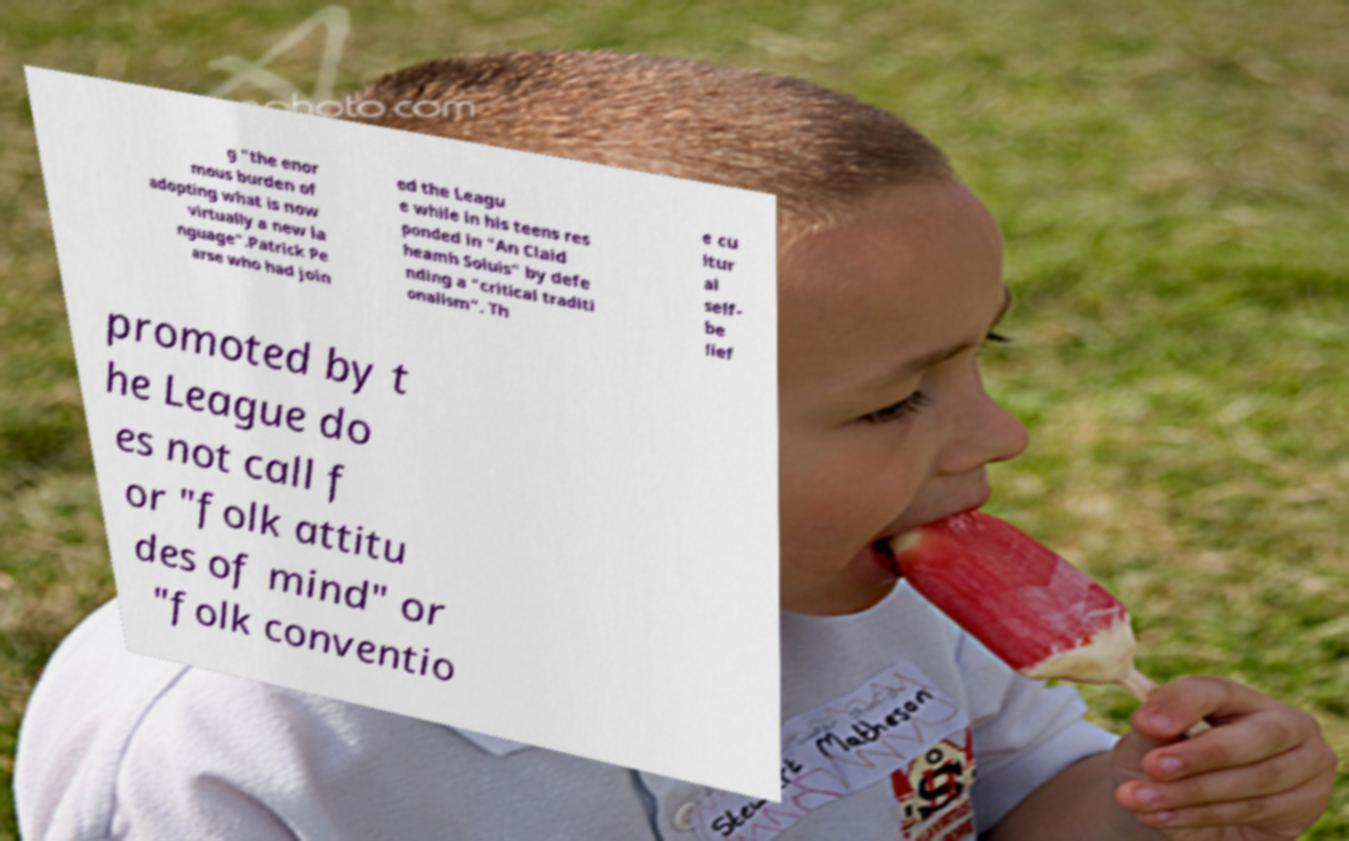Please read and relay the text visible in this image. What does it say? g "the enor mous burden of adopting what is now virtually a new la nguage".Patrick Pe arse who had join ed the Leagu e while in his teens res ponded in "An Claid heamh Soluis" by defe nding a "critical traditi onalism". Th e cu ltur al self- be lief promoted by t he League do es not call f or "folk attitu des of mind" or "folk conventio 